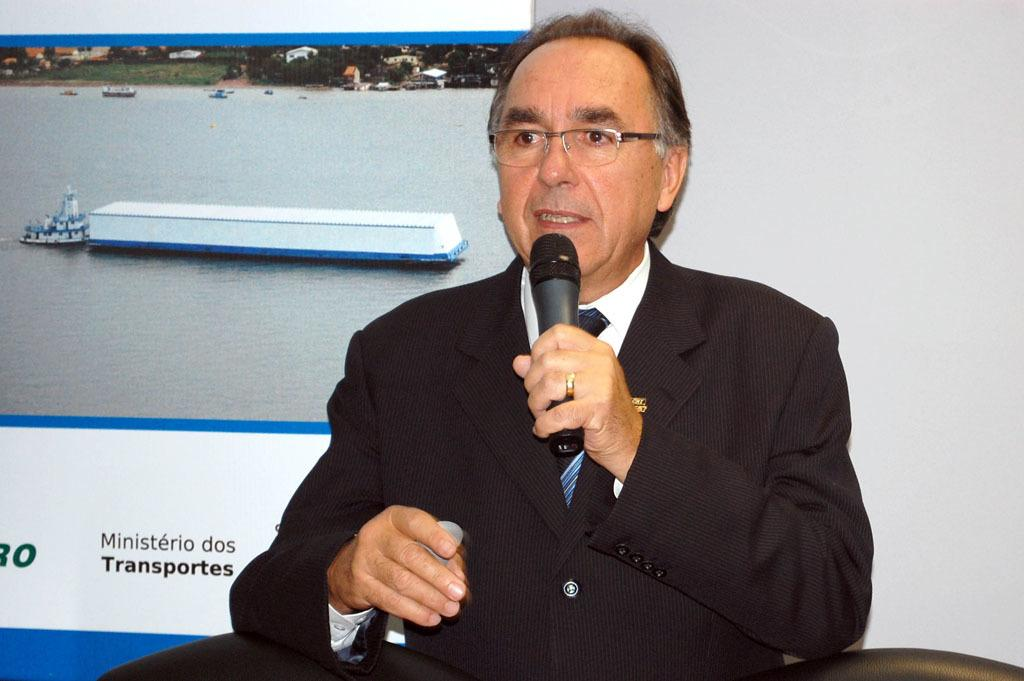Who is present in the image? There is a man in the image. What is the man wearing? The man is wearing a black coat. What is the man doing in the image? The man is sitting and speaking. What can be seen behind the man? There is a logo poster behind the man. What color is the wall on the right side of the image? The wall on the right side of the image is white. What type of sponge is being used by the man in the image? There is no sponge present in the image; the man is sitting and speaking. What country is the man from in the image? The country of origin of the man cannot be determined from the image. 